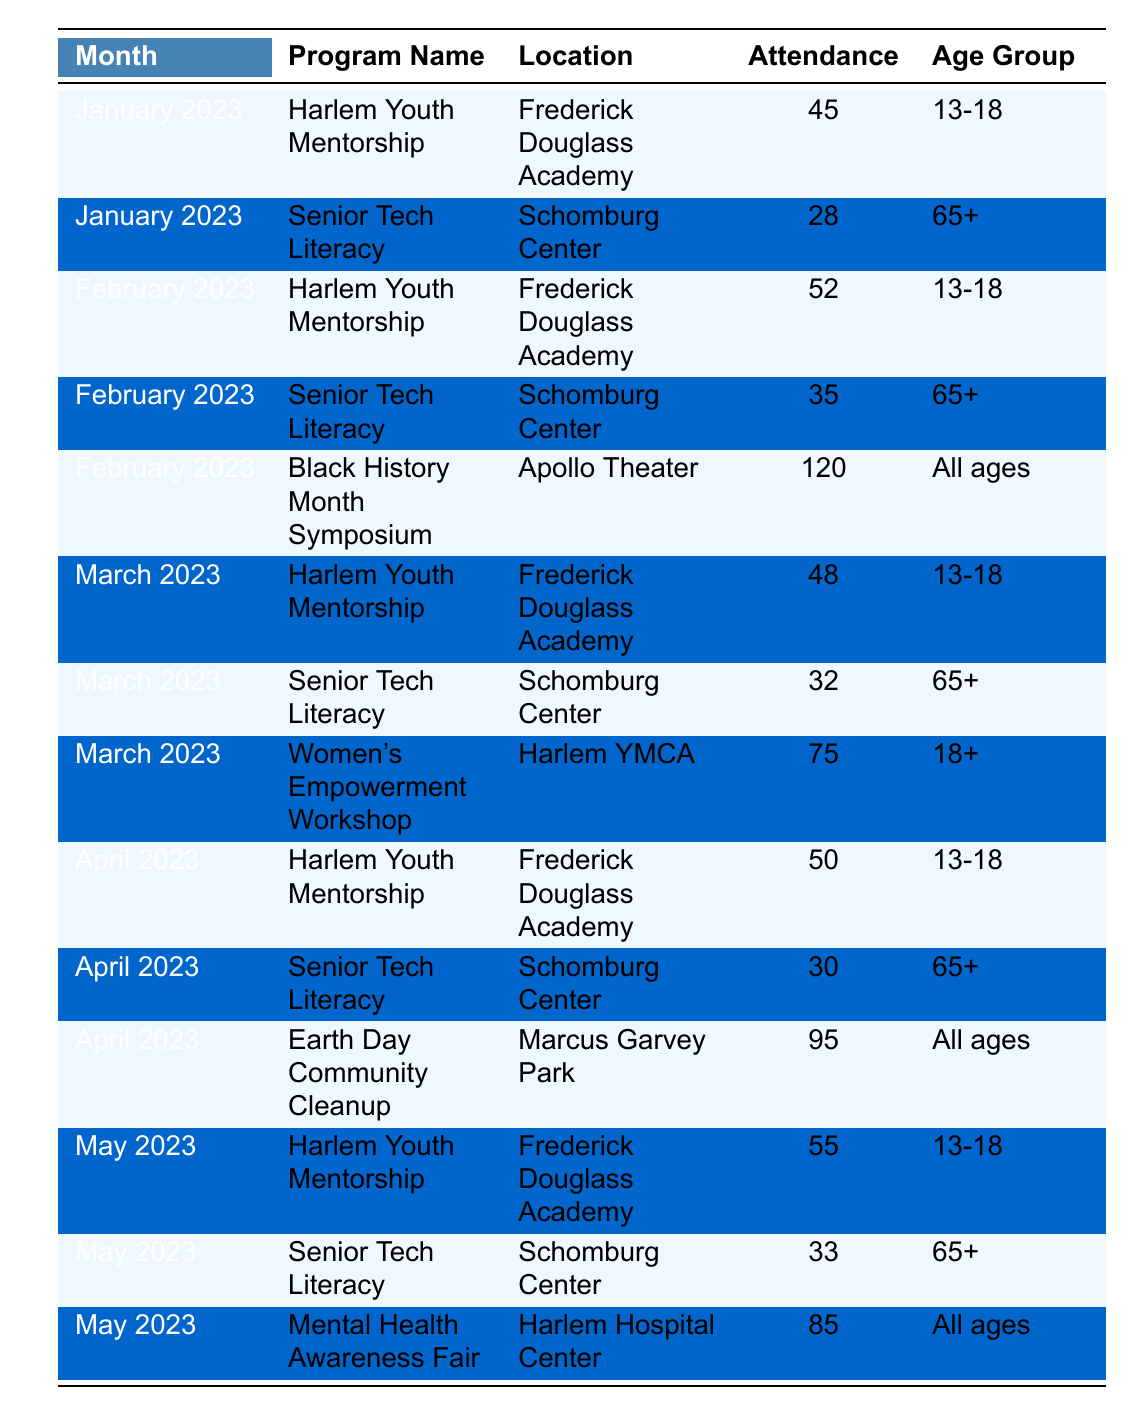What is the attendance for the "Women's Empowerment Workshop" in March 2023? The table lists the program "Women's Empowerment Workshop" under March 2023 with an attendance of 75.
Answer: 75 How many programs were held in January 2023? The table shows two programs in January 2023: "Harlem Youth Mentorship" and "Senior Tech Literacy." Therefore, there are two programs.
Answer: 2 Which program had the highest attendance in February 2023? In February 2023, "Black History Month Symposium" had an attendance of 120, which is higher than the 52 and 35 from the other two programs.
Answer: Black History Month Symposium What is the total attendance for "Harlem Youth Mentorship" from January to April 2023? The attendances for "Harlem Youth Mentorship" from January to April are 45, 52, 48, and 50, respectively. Adding these yields 45 + 52 + 48 + 50 = 195.
Answer: 195 Did the attendance for "Senior Tech Literacy" increase from January to February 2023? The attendance for "Senior Tech Literacy" was 28 in January and increased to 35 in February, which confirms it increased.
Answer: Yes Which month had the highest total attendance across all programs? To find this, we sum the attendances for each month. January = 73, February = 207, March = 155, April = 175, May = 173. February has the highest total attendance.
Answer: February 2023 What is the average attendance for "Senior Tech Literacy" across all reported months? The total attendance for "Senior Tech Literacy" in all months is 28 (Jan) + 35 (Feb) + 32 (Mar) + 30 (Apr) + 33 (May) = 158. There are 5 months, so the average is 158/5 = 31.6, rounded to 32.
Answer: 32 How many programs had an attendance of over 80? The table indicates "Black History Month Symposium" (120), "Earth Day Community Cleanup" (95), and "Mental Health Awareness Fair" (85) had over 80 attendees. Therefore, there are three such programs.
Answer: 3 What was the attendance difference between the highest and lowest attended program in April 2023? The highest attendance in April 2023 was for "Earth Day Community Cleanup" (95) and the lowest was "Senior Tech Literacy" (30). The difference is 95 - 30 = 65.
Answer: 65 Was there a program that had the same attendance in two different months? Upon reviewing the table, there are no programs with identical attendance values in different months.
Answer: No 